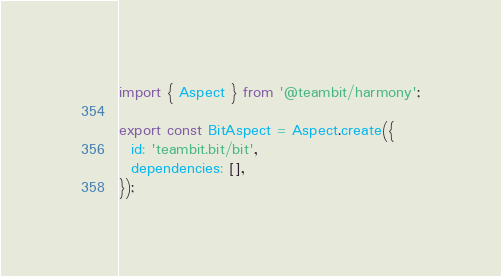Convert code to text. <code><loc_0><loc_0><loc_500><loc_500><_TypeScript_>import { Aspect } from '@teambit/harmony';

export const BitAspect = Aspect.create({
  id: 'teambit.bit/bit',
  dependencies: [],
});
</code> 